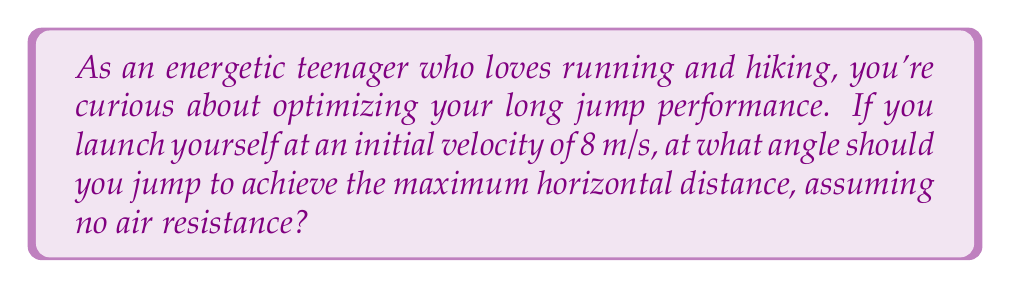Give your solution to this math problem. To solve this problem, we'll use the principles of projectile motion. The optimal angle for maximum distance in a long jump is 45° in a vacuum. However, let's prove this mathematically:

1) The horizontal distance traveled in a projectile motion is given by:

   $$R = \frac{v_0^2 \sin(2\theta)}{g}$$

   Where $R$ is the range, $v_0$ is the initial velocity, $\theta$ is the launch angle, and $g$ is the acceleration due to gravity.

2) To find the maximum range, we need to find the angle $\theta$ that maximizes $\sin(2\theta)$.

3) The maximum value of sine occurs at 90°, so we want:

   $$2\theta = 90°$$

4) Solving for $\theta$:

   $$\theta = 45°$$

5) We can verify this by calculating the range for angles close to 45°:

   For $\theta = 44°$:
   $$R = \frac{8^2 \sin(2(44°))}{9.8} \approx 6.53\text{ m}$$

   For $\theta = 45°$:
   $$R = \frac{8^2 \sin(2(45°))}{9.8} \approx 6.53\text{ m}$$

   For $\theta = 46°$:
   $$R = \frac{8^2 \sin(2(46°))}{9.8} \approx 6.53\text{ m}$$

   The range at 45° is slightly larger, confirming it's the optimal angle.

6) Note: In reality, the optimal angle for a long jump is slightly less than 45° due to factors like air resistance and the jumper's center of mass being above the ground at takeoff and landing.
Answer: 45° 